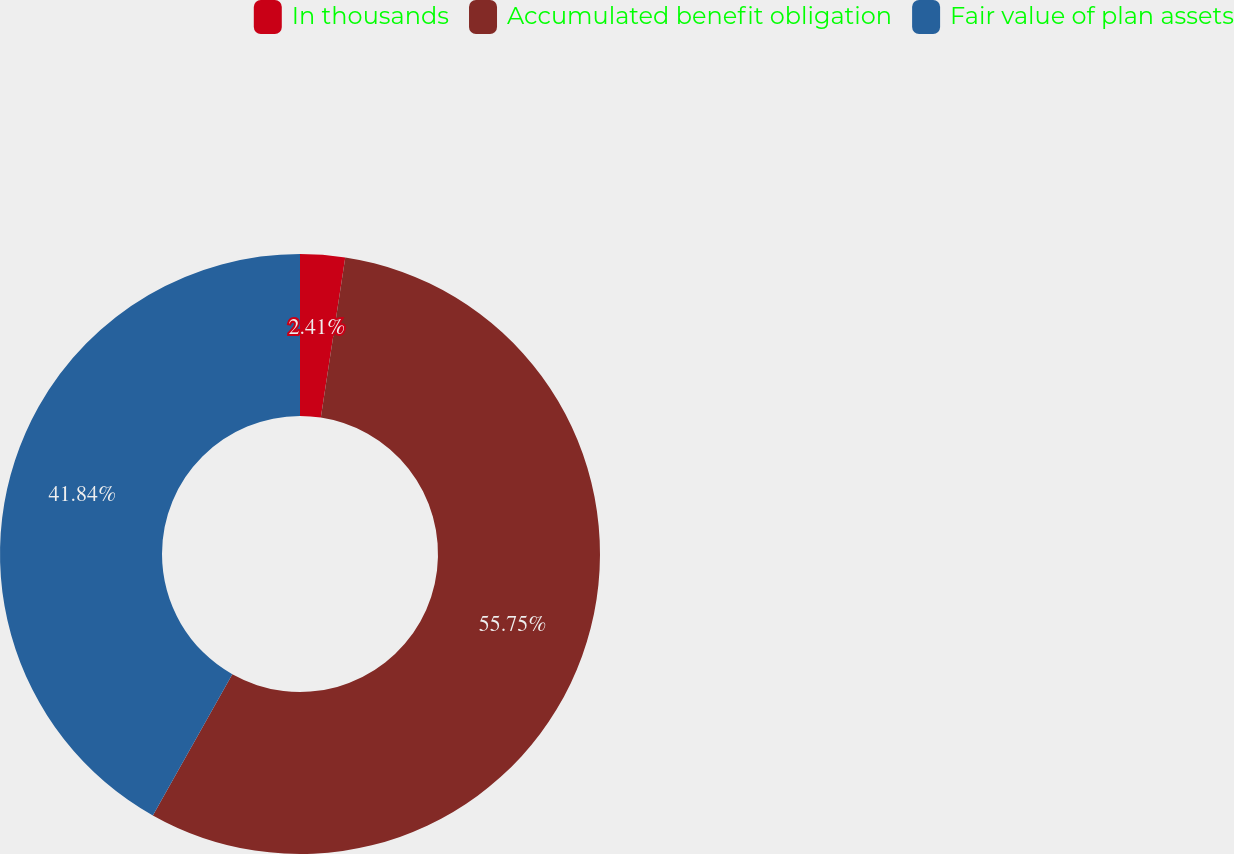Convert chart. <chart><loc_0><loc_0><loc_500><loc_500><pie_chart><fcel>In thousands<fcel>Accumulated benefit obligation<fcel>Fair value of plan assets<nl><fcel>2.41%<fcel>55.75%<fcel>41.84%<nl></chart> 